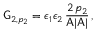<formula> <loc_0><loc_0><loc_500><loc_500>G _ { 2 , p _ { 2 } } = \epsilon _ { 1 } \epsilon _ { 2 } \, \frac { 2 \, p _ { 2 } } { A | A | } \, ,</formula> 